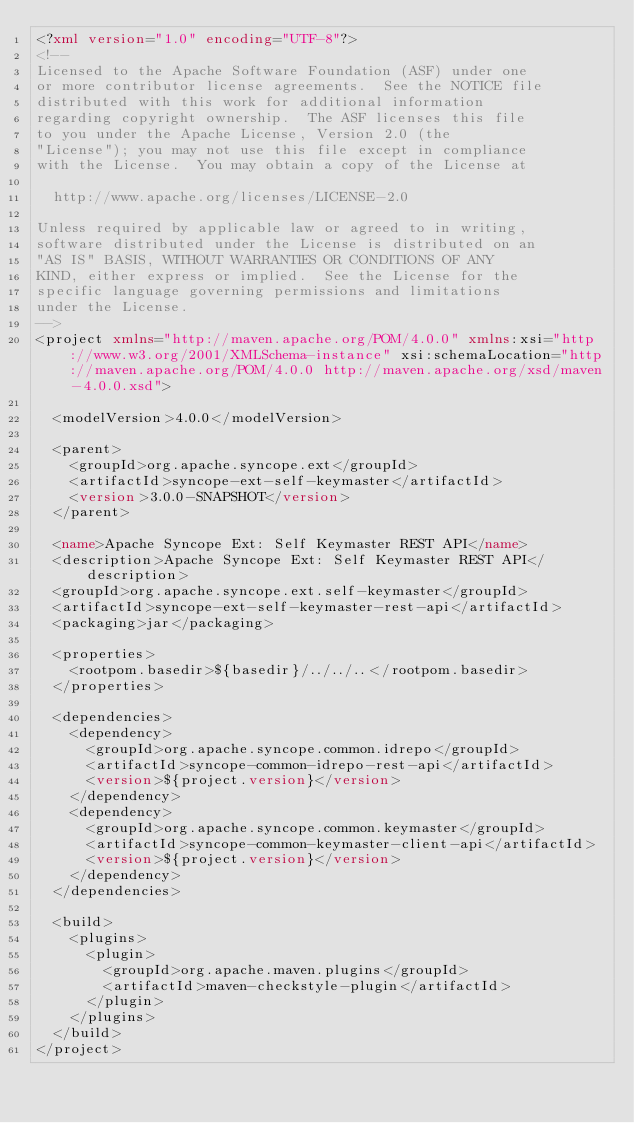<code> <loc_0><loc_0><loc_500><loc_500><_XML_><?xml version="1.0" encoding="UTF-8"?>
<!--
Licensed to the Apache Software Foundation (ASF) under one
or more contributor license agreements.  See the NOTICE file
distributed with this work for additional information
regarding copyright ownership.  The ASF licenses this file
to you under the Apache License, Version 2.0 (the
"License"); you may not use this file except in compliance
with the License.  You may obtain a copy of the License at

  http://www.apache.org/licenses/LICENSE-2.0

Unless required by applicable law or agreed to in writing,
software distributed under the License is distributed on an
"AS IS" BASIS, WITHOUT WARRANTIES OR CONDITIONS OF ANY
KIND, either express or implied.  See the License for the
specific language governing permissions and limitations
under the License.
-->
<project xmlns="http://maven.apache.org/POM/4.0.0" xmlns:xsi="http://www.w3.org/2001/XMLSchema-instance" xsi:schemaLocation="http://maven.apache.org/POM/4.0.0 http://maven.apache.org/xsd/maven-4.0.0.xsd">

  <modelVersion>4.0.0</modelVersion>

  <parent>
    <groupId>org.apache.syncope.ext</groupId>
    <artifactId>syncope-ext-self-keymaster</artifactId>
    <version>3.0.0-SNAPSHOT</version>
  </parent>

  <name>Apache Syncope Ext: Self Keymaster REST API</name>
  <description>Apache Syncope Ext: Self Keymaster REST API</description>
  <groupId>org.apache.syncope.ext.self-keymaster</groupId>
  <artifactId>syncope-ext-self-keymaster-rest-api</artifactId>
  <packaging>jar</packaging>
  
  <properties>
    <rootpom.basedir>${basedir}/../../..</rootpom.basedir>
  </properties>

  <dependencies>
    <dependency>
      <groupId>org.apache.syncope.common.idrepo</groupId>
      <artifactId>syncope-common-idrepo-rest-api</artifactId>
      <version>${project.version}</version>
    </dependency>
    <dependency>
      <groupId>org.apache.syncope.common.keymaster</groupId>
      <artifactId>syncope-common-keymaster-client-api</artifactId>
      <version>${project.version}</version>
    </dependency>
  </dependencies>

  <build>
    <plugins>
      <plugin>
        <groupId>org.apache.maven.plugins</groupId>
        <artifactId>maven-checkstyle-plugin</artifactId>
      </plugin>
    </plugins>
  </build>
</project>
</code> 